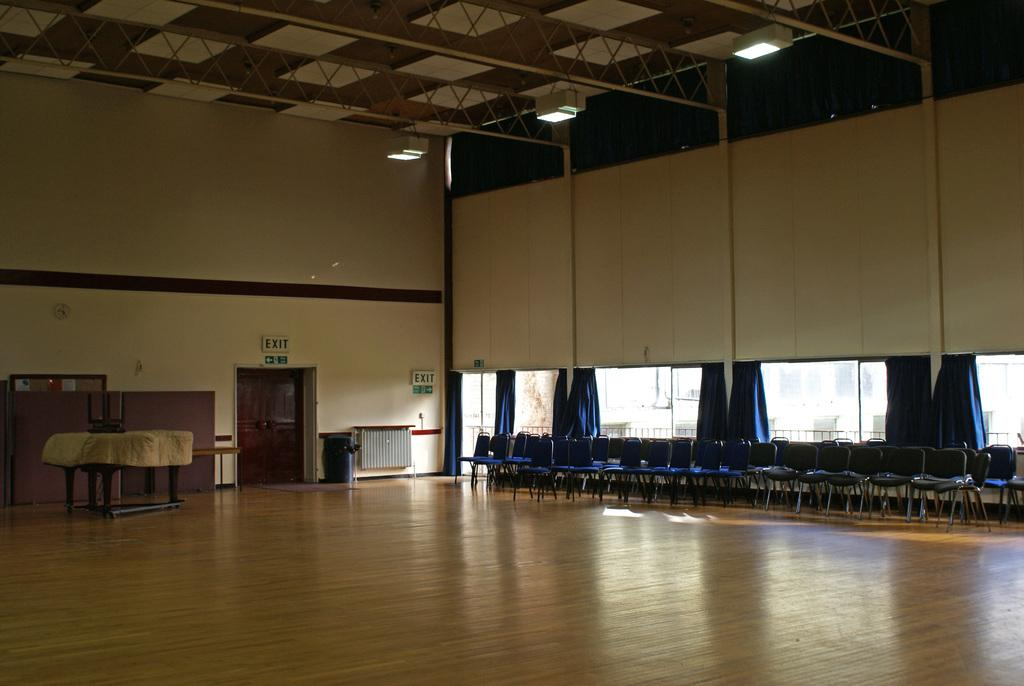What objects can be seen in the image that are typically used for sitting? There are empty chairs in the image. What objects can be seen in the image that allow access to different areas? There are doors in the image. What objects can be seen in the image that are used for covering windows? There are curtains in the image. What objects can be seen in the image that are attached to a wall? There is a wall with objects attached to it in the image. What objects can be seen in the image that provide illumination? There are lights on the ceiling in the image. What type of space is depicted in the image? The image is an inside view of a hall. What type of food is being served at the event in the image? There is no event or food present in the image; it depicts an empty hall with chairs, doors, curtains, wall decorations, and ceiling lights. Can you see any toes in the image? There are no toes visible in the image. 